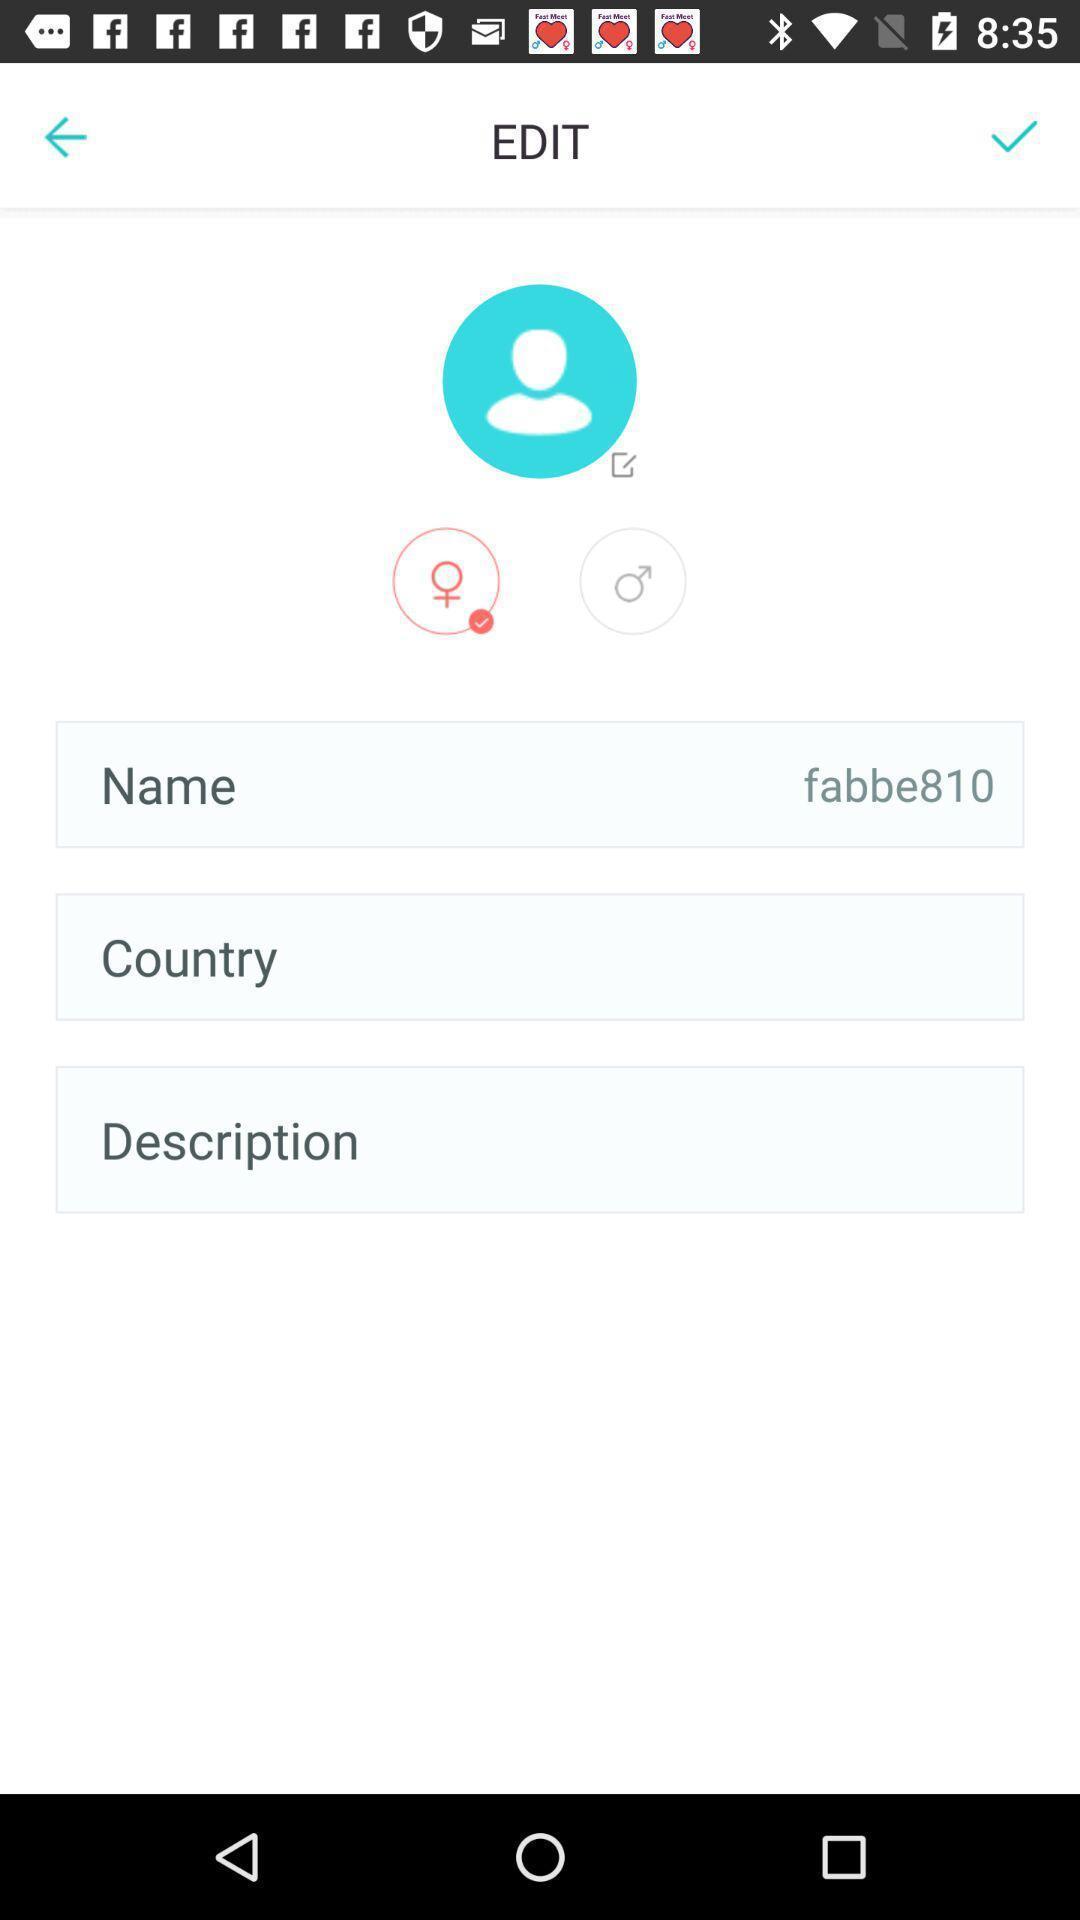Explain what's happening in this screen capture. Page showing profile page. 